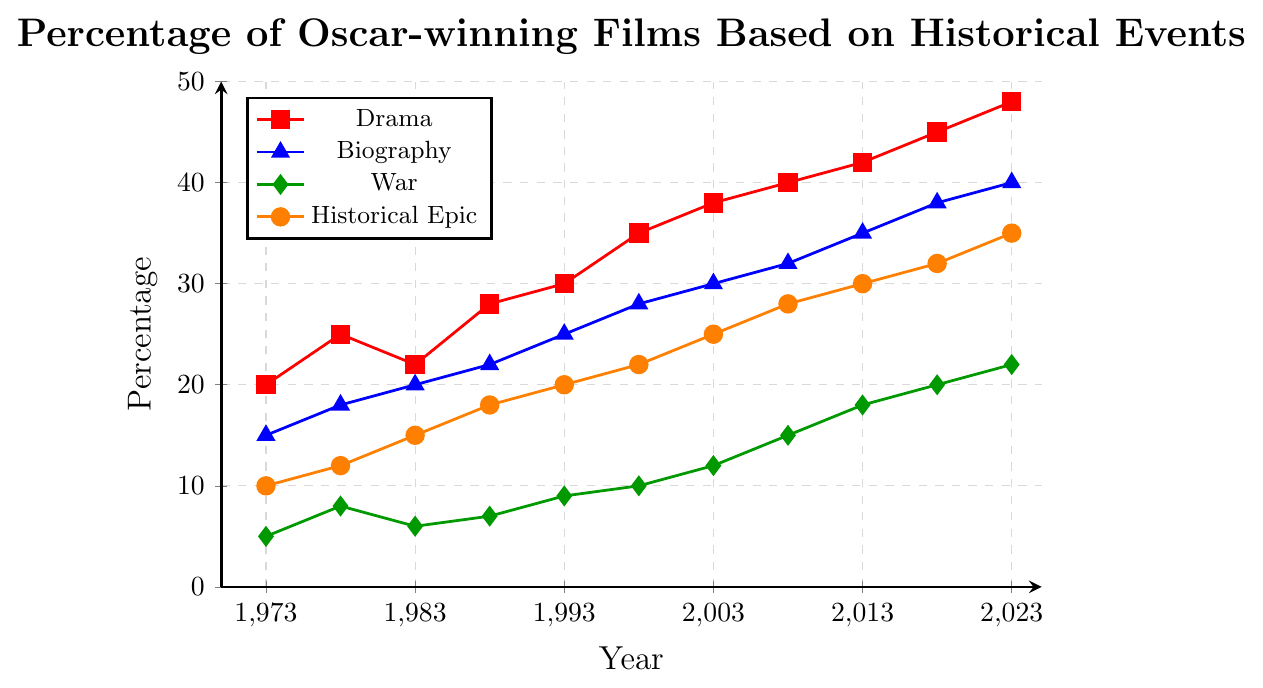Which genre had the highest percentage in 1988? Look at the 1988 data points for each genre (Drama, Biography, War, Historical Epic). Compare the values: Drama (28%), Biography (22%), War (7%), Historical Epic (18%). Drama has the highest percentage.
Answer: Drama What is the overall trend for the Biography genre from 1973 to 2023? Observe the blue line representing the Biography genre. Note how the percentage increases from 15% in 1973 to 40% in 2023. The overall trend is upward.
Answer: Increasing By how much did the percentage of War films increase from 1973 to 2023? Find the difference between the War percentage in 2023 (22%) and in 1973 (5%). Calculate 22% - 5% = 17%.
Answer: 17% Which year had equal percentages for both War and Historical Epic genres? Compare the green and orange lines. In 2013, both War (18%) and Historical Epic (30%) have different values, but similarly, check for correspondences in other years. This question is tricky as no years exactly match.
Answer: None In 2023, which genre had the second-highest percentage? Look at the 2023 data points for each genre: Drama (48%), Biography (40%), War (22%), Historical Epic (35%). Biography has the second-highest percentage.
Answer: Biography How much did the percentage of Drama films increase between 1998 and 2003? Look at the Drama percentages in 1998 (35%) and 2003 (38%). Calculate 38% - 35% = 3%.
Answer: 3% What is the average percentage of Historical Epic films from 1973 to 2023? Sum the percentages for Historical Epic: 10% + 12% + 15% + 18% + 20% + 22% + 25% + 28% + 30% + 32% + 35% = 247%. Divide by the number of data points (11). 247% / 11 = 22.45%.
Answer: 22.45% Which genre shows the steepest increase between any two consecutive data points? Compare the slopes of the lines between consecutive points for each genre. Note the increases, for instance, War from 2003 (12%) to 2008 (15%) shows a 3% increase, but the steepest observed is Biography from 2013 (35%) to 2018 (38%) with a 3% increase. The absolute steepest covers the Drama’s 45 to 48 jump from 2018 to 2023 at 3%. Hence, the Drama genre displays the highest increase.
Answer: Drama 